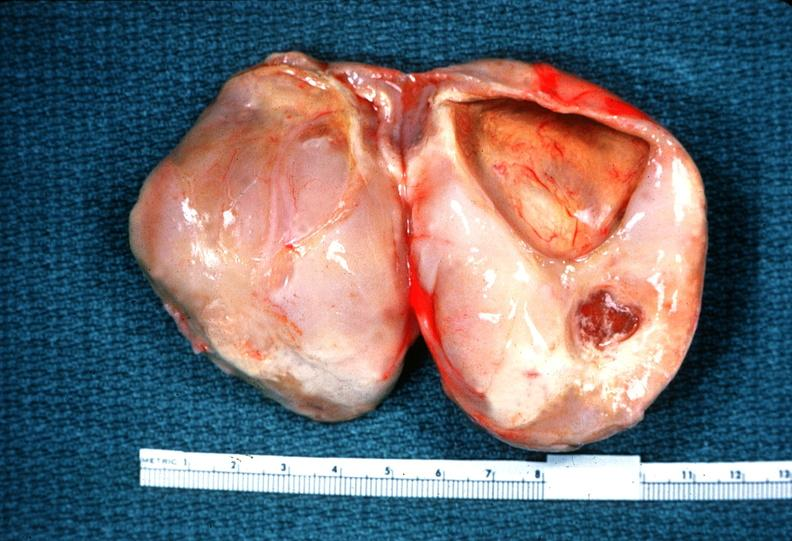what is present?
Answer the question using a single word or phrase. Nervous 